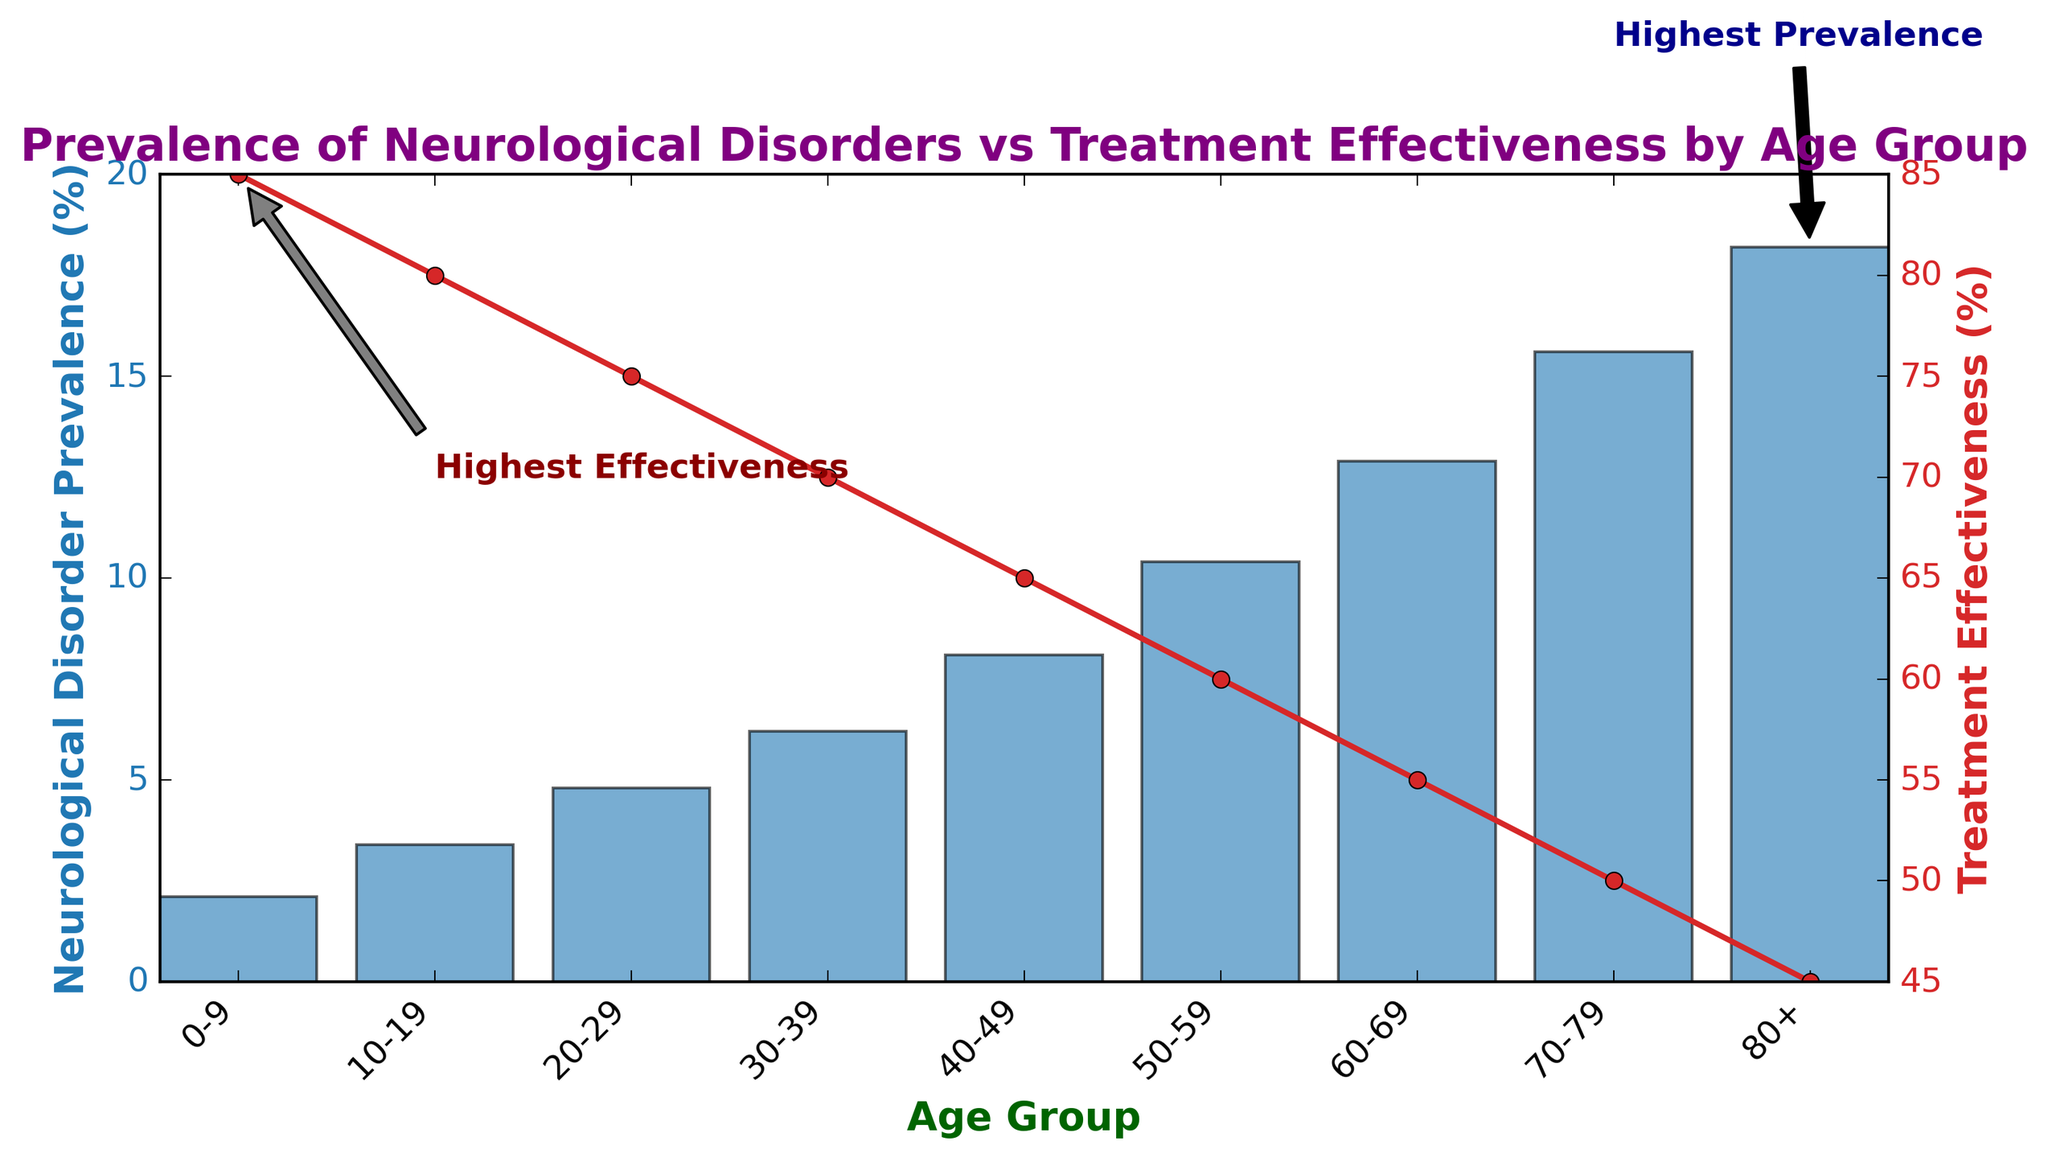What is the prevalence of neurological disorders in the 40-49 age group? The prevalence for each age group is indicated by the heights of the blue bars on the left y-axis. In the 40-49 age group, the bar corresponding to this age group reaches the 8.1% mark on the y-axis.
Answer: 8.1% What is the treatment effectiveness for the 0-9 age group? The treatment effectiveness for each age group is shown by the points connected by the red line on the right y-axis. The point for the 0-9 age group reaches the 85% mark on the y-axis.
Answer: 85% Which age group has the highest prevalence of neurological disorders? The age group corresponding to the highest blue bar indicates the highest prevalence. The 80+ age group has the tallest blue bar, signifying the highest prevalence.
Answer: 80+ Which age group has the lowest treatment effectiveness? The age group with the lowest point in the red line graph corresponds to the lowest treatment effectiveness. The 80+ age group has the lowest point at 45%.
Answer: 80+ How much higher is the prevalence of neurological disorders in the 70-79 age group compared to the 20-29 age group? The prevalence for the 70-79 age group is 15.6% and for the 20-29 age group, it is 4.8%. The difference is 15.6% - 4.8%.
Answer: 10.8% Does the treatment effectiveness decrease or increase with age? Observing the trend of the red line, it shows a downward slope from left to right, indicating that treatment effectiveness decreases as age increases.
Answer: Decrease What is the difference in treatment effectiveness between the 40-49 and 60-69 age groups? The treatment effectiveness for the 40-49 age group is 65%, and for the 60-69 age group, it is 55%. The difference is 65% - 55%.
Answer: 10% What is the average prevalence of neurological disorders across all age groups? Sum all prevalence percentages and divide by the number of age groups: (2.1 + 3.4 + 4.8 + 6.2 + 8.1 + 10.4 + 12.9 + 15.6 + 18.2) / 9.
Answer: 9% How is the relationship between prevalence and treatment effectiveness visually represented? The prevalence is shown using blue bars while the treatment effectiveness is plotted with a red line, indicating two different y-axes on the left and right respectively.
Answer: Blue bars and red line 